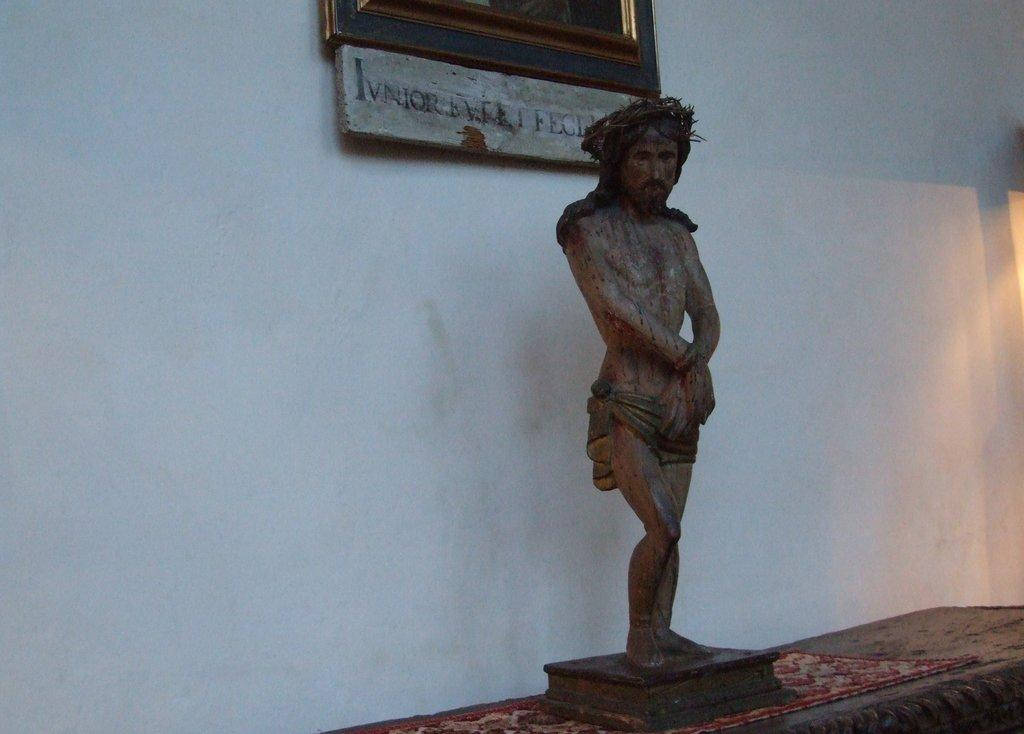What is the main subject of the image? There is a statue in the image. Where is the statue located? The statue is on a platform. What can be seen in the background of the image? There is a board and a frame on the wall in the background of the image. What type of rose is depicted in the caption of the image? There is no rose or caption present in the image. How many stalks of celery are visible in the frame on the wall? There is no celery present in the image, and the frame on the wall does not contain any visible objects. 